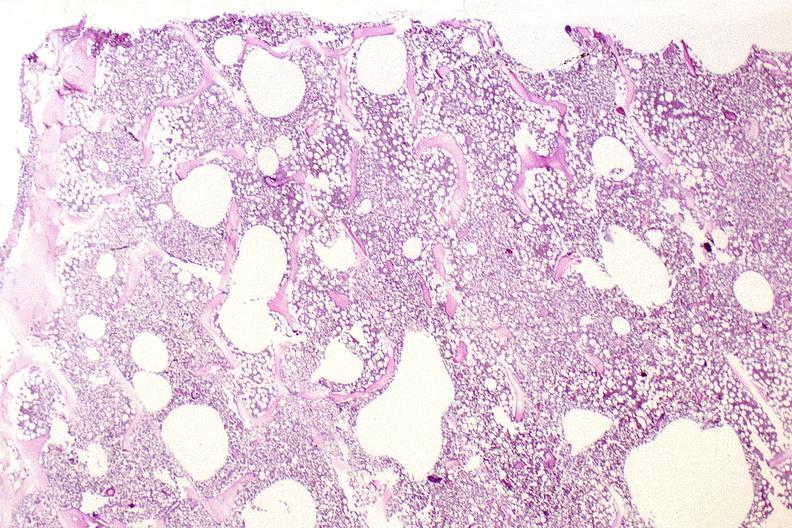what is present?
Answer the question using a single word or phrase. Musculoskeletal 